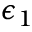Convert formula to latex. <formula><loc_0><loc_0><loc_500><loc_500>\epsilon _ { 1 }</formula> 